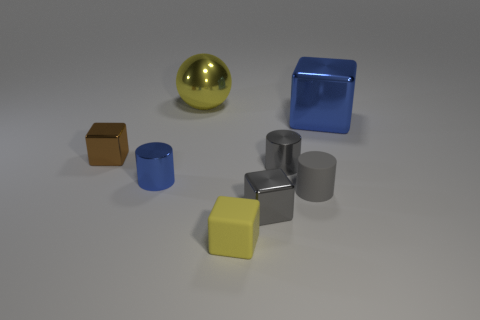What number of balls are the same size as the blue cube?
Provide a short and direct response. 1. What is the material of the brown thing that is the same shape as the small yellow rubber object?
Offer a terse response. Metal. Does the large object that is in front of the large yellow metallic sphere have the same color as the tiny object to the left of the small blue cylinder?
Your answer should be compact. No. What is the shape of the small gray matte thing in front of the yellow sphere?
Make the answer very short. Cylinder. What color is the large metallic sphere?
Keep it short and to the point. Yellow. What is the shape of the small gray object that is made of the same material as the gray block?
Offer a very short reply. Cylinder. Do the metal block in front of the brown thing and the big yellow shiny sphere have the same size?
Your answer should be very brief. No. How many objects are small things that are right of the large yellow sphere or shiny objects on the right side of the large yellow metal object?
Provide a short and direct response. 5. Do the thing that is in front of the tiny gray metallic block and the big metallic ball have the same color?
Your answer should be very brief. Yes. How many matte things are either large things or tiny blue things?
Your answer should be very brief. 0. 